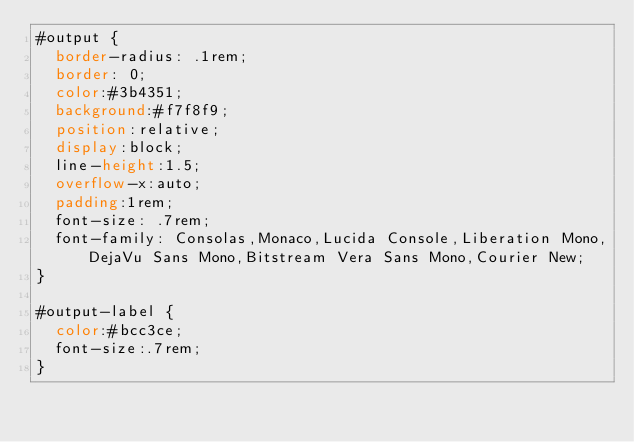Convert code to text. <code><loc_0><loc_0><loc_500><loc_500><_CSS_>#output {
  border-radius: .1rem;
  border: 0;
  color:#3b4351;
  background:#f7f8f9;
  position:relative;
  display:block;
  line-height:1.5;
  overflow-x:auto;
  padding:1rem;
  font-size: .7rem;
  font-family: Consolas,Monaco,Lucida Console,Liberation Mono,DejaVu Sans Mono,Bitstream Vera Sans Mono,Courier New;
}

#output-label {
  color:#bcc3ce;
  font-size:.7rem;
}
</code> 